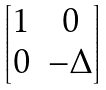Convert formula to latex. <formula><loc_0><loc_0><loc_500><loc_500>\begin{bmatrix} 1 & 0 \\ 0 & - \Delta \end{bmatrix}</formula> 